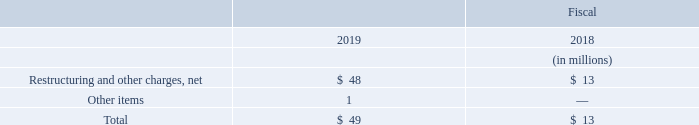In the Communications Solutions segment, operating income decreased $79 million in fiscal 2019 as compared to fiscal 2018. The Communications Solutions segment’s operating income included the following:
Excluding these items, operating income decreased in fiscal 2019 due primarily to lower volume.
What was the change in operating income in the Communications Solutions segment in 2019? Decreased $79 million. Why did operating income decrease in fiscal 2019? Due primarily to lower volume. What are the items under the operating income in the Communications Solutions segment? Restructuring and other charges, net, other items. In which year was Restructuring and other charges, net larger? 48>13
Answer: 2019. What was the change in Total operating income in the Communications Solutions segment in 2019 from 2018?
Answer scale should be: million. 49-13
Answer: 36. What was the percentage change in Total operating income in the Communications Solutions segment in 2019 from 2018?
Answer scale should be: percent. (49-13)/13
Answer: 276.92. 